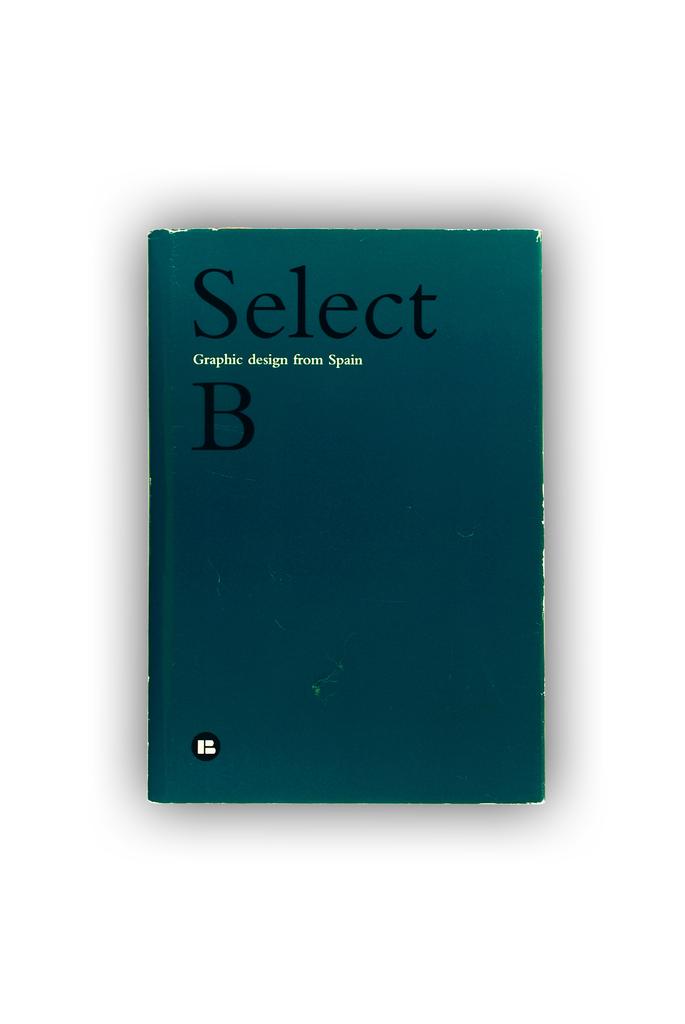What country is this book from?
Ensure brevity in your answer.  Spain. What is the title of this book?
Offer a very short reply. Select b. 